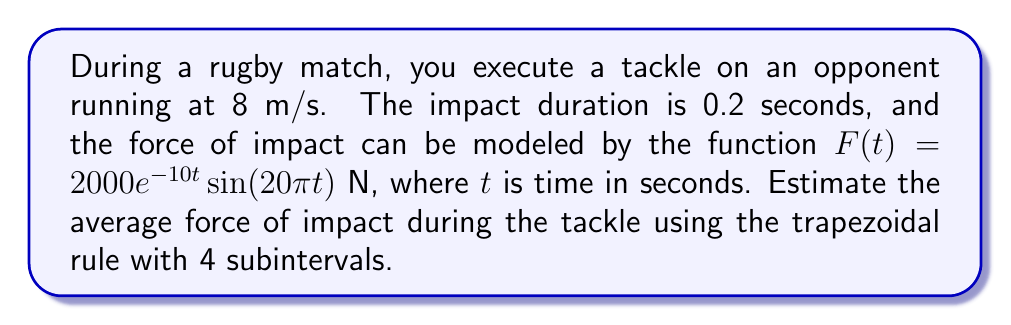Solve this math problem. To estimate the average force of impact, we need to:
1. Set up the integral for the average force
2. Apply the trapezoidal rule
3. Calculate the result

Step 1: Set up the integral
The average force is given by:
$$\bar{F} = \frac{1}{b-a}\int_a^b F(t) dt$$
where $a=0$ and $b=0.2$

Step 2: Apply the trapezoidal rule
The trapezoidal rule with $n$ subintervals is:
$$\int_a^b f(x)dx \approx \frac{b-a}{2n}\left[f(a) + 2\sum_{i=1}^{n-1}f(x_i) + f(b)\right]$$

For $n=4$, $h = \frac{b-a}{n} = \frac{0.2}{4} = 0.05$

Calculate function values:
$F(0) = 0$
$F(0.05) = 2000e^{-0.5} \sin(\pi) = 1213.63$
$F(0.1) = 2000e^{-1} \sin(2\pi) = 0$
$F(0.15) = 2000e^{-1.5} \sin(3\pi) = -443.34$
$F(0.2) = 2000e^{-2} \sin(4\pi) = 0$

Apply the formula:
$$\int_0^{0.2} F(t)dt \approx \frac{0.2}{2(4)}[0 + 2(1213.63 + 0 - 443.34) + 0] = 38.53$$

Step 3: Calculate the average force
$$\bar{F} = \frac{1}{0.2}\int_0^{0.2} F(t)dt \approx \frac{38.53}{0.2} = 192.65\text{ N}$$
Answer: 192.65 N 